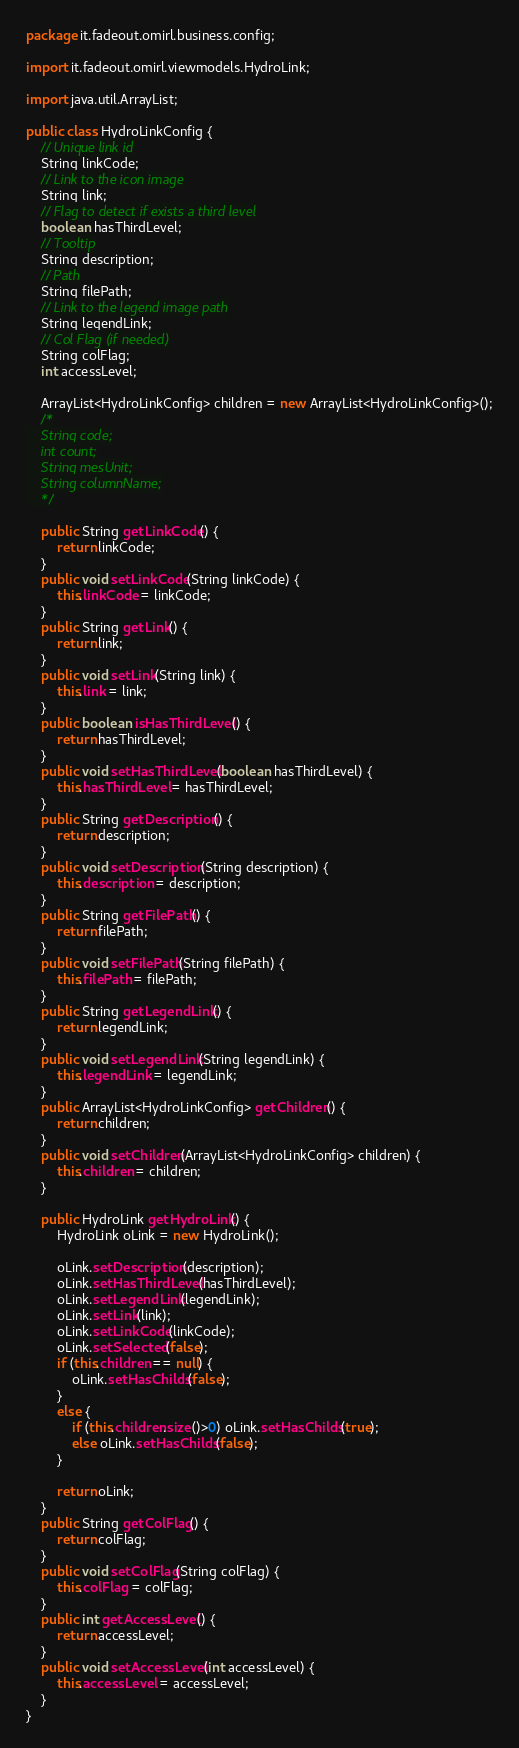Convert code to text. <code><loc_0><loc_0><loc_500><loc_500><_Java_>package it.fadeout.omirl.business.config;

import it.fadeout.omirl.viewmodels.HydroLink;

import java.util.ArrayList;

public class HydroLinkConfig {
	// Unique link id
	String linkCode;	
	// Link to the icon image
	String link;
	// Flag to detect if exists a third level
	boolean hasThirdLevel;
	// Tooltip
	String description;
	// Path
	String filePath;
	// Link to the legend image path
	String legendLink;
	// Col Flag (if needed)
	String colFlag;
	int accessLevel;
	
	ArrayList<HydroLinkConfig> children = new ArrayList<HydroLinkConfig>();
	/*
	String code;
	int count;
	String mesUnit;
	String columnName;
	*/	
	
	public String getLinkCode() {
		return linkCode;
	}
	public void setLinkCode(String linkCode) {
		this.linkCode = linkCode;
	}
	public String getLink() {
		return link;
	}
	public void setLink(String link) {
		this.link = link;
	}
	public boolean isHasThirdLevel() {
		return hasThirdLevel;
	}
	public void setHasThirdLevel(boolean hasThirdLevel) {
		this.hasThirdLevel = hasThirdLevel;
	}
	public String getDescription() {
		return description;
	}
	public void setDescription(String description) {
		this.description = description;
	}
	public String getFilePath() {
		return filePath;
	}
	public void setFilePath(String filePath) {
		this.filePath = filePath;
	}
	public String getLegendLink() {
		return legendLink;
	}
	public void setLegendLink(String legendLink) {
		this.legendLink = legendLink;
	}
	public ArrayList<HydroLinkConfig> getChildren() {
		return children;
	}
	public void setChildren(ArrayList<HydroLinkConfig> children) {
		this.children = children;
	}
	
	public HydroLink getHydroLink() {
		HydroLink oLink = new HydroLink();
		
		oLink.setDescription(description);
		oLink.setHasThirdLevel(hasThirdLevel);
		oLink.setLegendLink(legendLink);
		oLink.setLink(link);
		oLink.setLinkCode(linkCode);
		oLink.setSelected(false);
		if (this.children == null) {
			oLink.setHasChilds(false);
		}
		else {
			if (this.children.size()>0) oLink.setHasChilds(true);
			else oLink.setHasChilds(false);
		}
		
		return oLink;
	}
	public String getColFlag() {
		return colFlag;
	}
	public void setColFlag(String colFlag) {
		this.colFlag = colFlag;
	}
	public int getAccessLevel() {
		return accessLevel;
	}
	public void setAccessLevel(int accessLevel) {
		this.accessLevel = accessLevel;
	}
}
</code> 